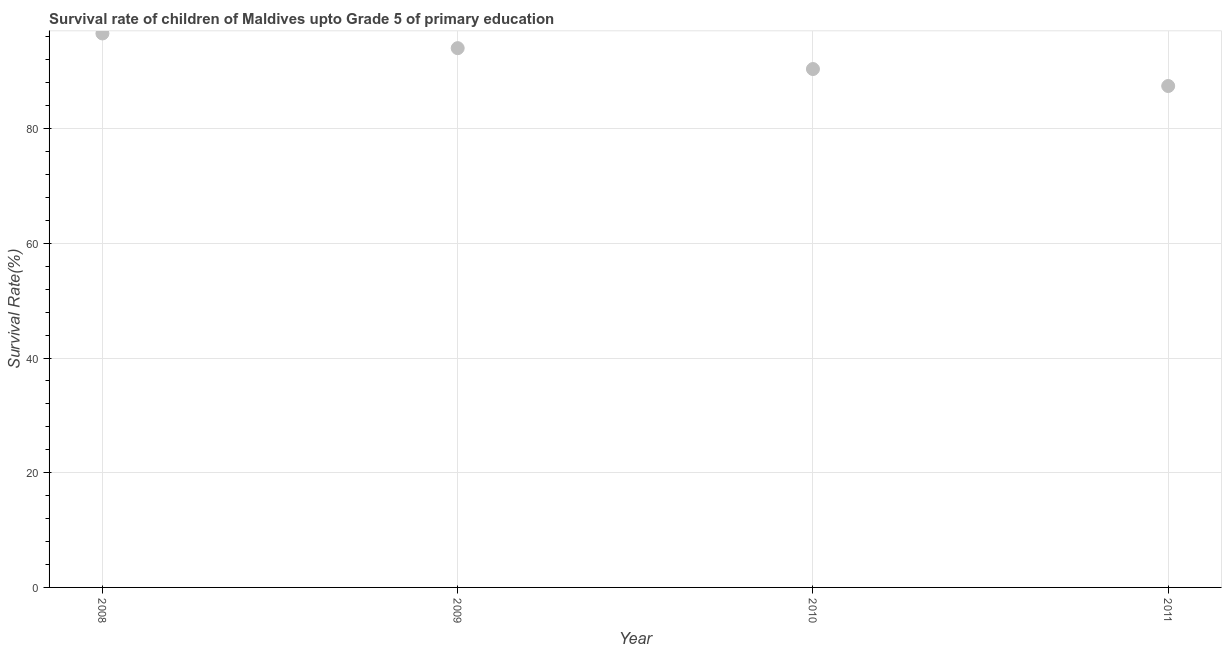What is the survival rate in 2009?
Your response must be concise. 94.04. Across all years, what is the maximum survival rate?
Offer a very short reply. 96.61. Across all years, what is the minimum survival rate?
Provide a succinct answer. 87.44. In which year was the survival rate minimum?
Give a very brief answer. 2011. What is the sum of the survival rate?
Ensure brevity in your answer.  368.5. What is the difference between the survival rate in 2008 and 2009?
Offer a very short reply. 2.56. What is the average survival rate per year?
Offer a very short reply. 92.12. What is the median survival rate?
Offer a terse response. 92.22. What is the ratio of the survival rate in 2009 to that in 2010?
Provide a succinct answer. 1.04. Is the difference between the survival rate in 2008 and 2011 greater than the difference between any two years?
Your response must be concise. Yes. What is the difference between the highest and the second highest survival rate?
Offer a very short reply. 2.56. Is the sum of the survival rate in 2009 and 2010 greater than the maximum survival rate across all years?
Your answer should be compact. Yes. What is the difference between the highest and the lowest survival rate?
Provide a short and direct response. 9.17. How many dotlines are there?
Your response must be concise. 1. Does the graph contain any zero values?
Make the answer very short. No. Does the graph contain grids?
Give a very brief answer. Yes. What is the title of the graph?
Provide a short and direct response. Survival rate of children of Maldives upto Grade 5 of primary education. What is the label or title of the X-axis?
Provide a succinct answer. Year. What is the label or title of the Y-axis?
Your response must be concise. Survival Rate(%). What is the Survival Rate(%) in 2008?
Your response must be concise. 96.61. What is the Survival Rate(%) in 2009?
Your answer should be very brief. 94.04. What is the Survival Rate(%) in 2010?
Ensure brevity in your answer.  90.4. What is the Survival Rate(%) in 2011?
Your answer should be very brief. 87.44. What is the difference between the Survival Rate(%) in 2008 and 2009?
Ensure brevity in your answer.  2.56. What is the difference between the Survival Rate(%) in 2008 and 2010?
Ensure brevity in your answer.  6.21. What is the difference between the Survival Rate(%) in 2008 and 2011?
Offer a very short reply. 9.17. What is the difference between the Survival Rate(%) in 2009 and 2010?
Your answer should be very brief. 3.64. What is the difference between the Survival Rate(%) in 2009 and 2011?
Make the answer very short. 6.6. What is the difference between the Survival Rate(%) in 2010 and 2011?
Offer a terse response. 2.96. What is the ratio of the Survival Rate(%) in 2008 to that in 2010?
Your response must be concise. 1.07. What is the ratio of the Survival Rate(%) in 2008 to that in 2011?
Provide a short and direct response. 1.1. What is the ratio of the Survival Rate(%) in 2009 to that in 2010?
Keep it short and to the point. 1.04. What is the ratio of the Survival Rate(%) in 2009 to that in 2011?
Offer a terse response. 1.08. What is the ratio of the Survival Rate(%) in 2010 to that in 2011?
Give a very brief answer. 1.03. 